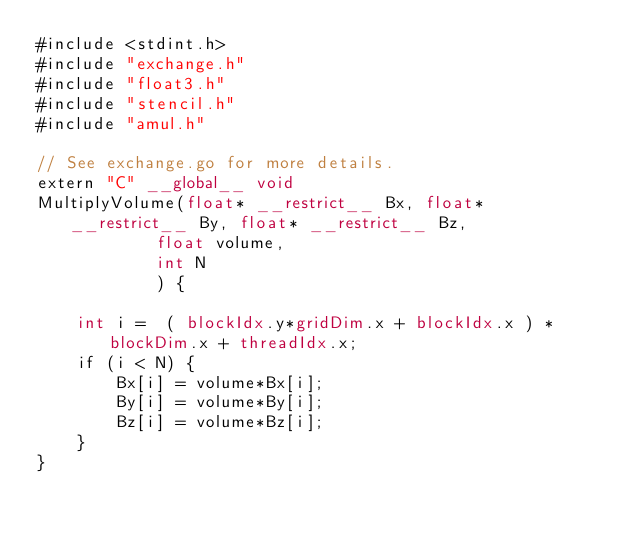Convert code to text. <code><loc_0><loc_0><loc_500><loc_500><_Cuda_>#include <stdint.h>
#include "exchange.h"
#include "float3.h"
#include "stencil.h"
#include "amul.h"

// See exchange.go for more details.
extern "C" __global__ void
MultiplyVolume(float* __restrict__ Bx, float* __restrict__ By, float* __restrict__ Bz,
            float volume,
            int N
            ) {

    int i =  ( blockIdx.y*gridDim.x + blockIdx.x ) * blockDim.x + threadIdx.x;
    if (i < N) {
        Bx[i] = volume*Bx[i];
        By[i] = volume*By[i];
        Bz[i] = volume*Bz[i];
    }
}</code> 